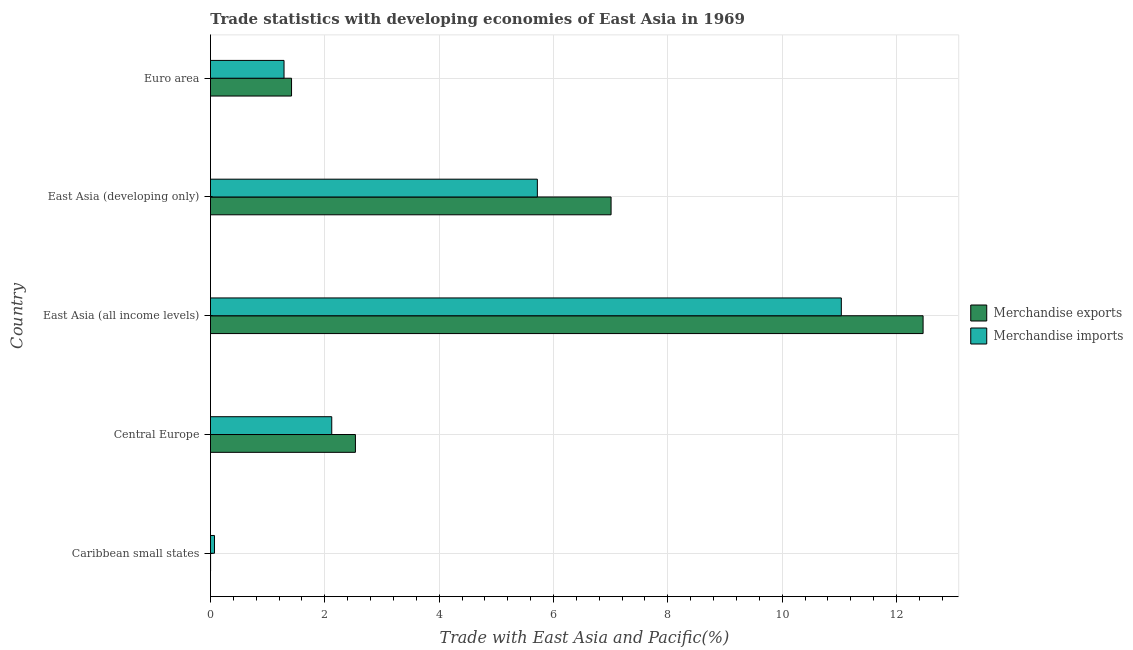How many different coloured bars are there?
Your answer should be very brief. 2. How many bars are there on the 1st tick from the top?
Keep it short and to the point. 2. What is the label of the 5th group of bars from the top?
Your answer should be compact. Caribbean small states. What is the merchandise imports in East Asia (all income levels)?
Your response must be concise. 11.03. Across all countries, what is the maximum merchandise exports?
Offer a very short reply. 12.46. Across all countries, what is the minimum merchandise imports?
Your answer should be compact. 0.07. In which country was the merchandise imports maximum?
Your response must be concise. East Asia (all income levels). In which country was the merchandise exports minimum?
Provide a succinct answer. Caribbean small states. What is the total merchandise imports in the graph?
Offer a terse response. 20.23. What is the difference between the merchandise exports in Caribbean small states and that in Euro area?
Provide a succinct answer. -1.42. What is the difference between the merchandise imports in Central Europe and the merchandise exports in Caribbean small states?
Offer a terse response. 2.12. What is the average merchandise imports per country?
Offer a very short reply. 4.05. What is the difference between the merchandise exports and merchandise imports in Caribbean small states?
Make the answer very short. -0.07. In how many countries, is the merchandise imports greater than 2.4 %?
Your response must be concise. 2. What is the ratio of the merchandise exports in East Asia (all income levels) to that in East Asia (developing only)?
Provide a short and direct response. 1.78. Is the merchandise imports in Caribbean small states less than that in Central Europe?
Provide a short and direct response. Yes. What is the difference between the highest and the second highest merchandise exports?
Provide a short and direct response. 5.46. What is the difference between the highest and the lowest merchandise exports?
Keep it short and to the point. 12.46. What does the 1st bar from the top in Caribbean small states represents?
Provide a short and direct response. Merchandise imports. Are all the bars in the graph horizontal?
Offer a very short reply. Yes. How many countries are there in the graph?
Make the answer very short. 5. What is the difference between two consecutive major ticks on the X-axis?
Your answer should be very brief. 2. Does the graph contain any zero values?
Ensure brevity in your answer.  No. Does the graph contain grids?
Ensure brevity in your answer.  Yes. How many legend labels are there?
Make the answer very short. 2. What is the title of the graph?
Your response must be concise. Trade statistics with developing economies of East Asia in 1969. What is the label or title of the X-axis?
Your response must be concise. Trade with East Asia and Pacific(%). What is the Trade with East Asia and Pacific(%) of Merchandise exports in Caribbean small states?
Offer a very short reply. 0. What is the Trade with East Asia and Pacific(%) of Merchandise imports in Caribbean small states?
Keep it short and to the point. 0.07. What is the Trade with East Asia and Pacific(%) in Merchandise exports in Central Europe?
Make the answer very short. 2.54. What is the Trade with East Asia and Pacific(%) of Merchandise imports in Central Europe?
Provide a short and direct response. 2.12. What is the Trade with East Asia and Pacific(%) of Merchandise exports in East Asia (all income levels)?
Offer a terse response. 12.46. What is the Trade with East Asia and Pacific(%) of Merchandise imports in East Asia (all income levels)?
Your answer should be very brief. 11.03. What is the Trade with East Asia and Pacific(%) in Merchandise exports in East Asia (developing only)?
Make the answer very short. 7.01. What is the Trade with East Asia and Pacific(%) in Merchandise imports in East Asia (developing only)?
Ensure brevity in your answer.  5.72. What is the Trade with East Asia and Pacific(%) in Merchandise exports in Euro area?
Give a very brief answer. 1.42. What is the Trade with East Asia and Pacific(%) of Merchandise imports in Euro area?
Your response must be concise. 1.29. Across all countries, what is the maximum Trade with East Asia and Pacific(%) of Merchandise exports?
Give a very brief answer. 12.46. Across all countries, what is the maximum Trade with East Asia and Pacific(%) in Merchandise imports?
Provide a short and direct response. 11.03. Across all countries, what is the minimum Trade with East Asia and Pacific(%) of Merchandise exports?
Offer a very short reply. 0. Across all countries, what is the minimum Trade with East Asia and Pacific(%) of Merchandise imports?
Your answer should be compact. 0.07. What is the total Trade with East Asia and Pacific(%) in Merchandise exports in the graph?
Offer a very short reply. 23.43. What is the total Trade with East Asia and Pacific(%) in Merchandise imports in the graph?
Keep it short and to the point. 20.23. What is the difference between the Trade with East Asia and Pacific(%) in Merchandise exports in Caribbean small states and that in Central Europe?
Keep it short and to the point. -2.53. What is the difference between the Trade with East Asia and Pacific(%) in Merchandise imports in Caribbean small states and that in Central Europe?
Offer a terse response. -2.05. What is the difference between the Trade with East Asia and Pacific(%) in Merchandise exports in Caribbean small states and that in East Asia (all income levels)?
Provide a short and direct response. -12.46. What is the difference between the Trade with East Asia and Pacific(%) of Merchandise imports in Caribbean small states and that in East Asia (all income levels)?
Make the answer very short. -10.96. What is the difference between the Trade with East Asia and Pacific(%) of Merchandise exports in Caribbean small states and that in East Asia (developing only)?
Provide a short and direct response. -7.01. What is the difference between the Trade with East Asia and Pacific(%) of Merchandise imports in Caribbean small states and that in East Asia (developing only)?
Your answer should be very brief. -5.65. What is the difference between the Trade with East Asia and Pacific(%) in Merchandise exports in Caribbean small states and that in Euro area?
Ensure brevity in your answer.  -1.42. What is the difference between the Trade with East Asia and Pacific(%) of Merchandise imports in Caribbean small states and that in Euro area?
Give a very brief answer. -1.22. What is the difference between the Trade with East Asia and Pacific(%) in Merchandise exports in Central Europe and that in East Asia (all income levels)?
Give a very brief answer. -9.93. What is the difference between the Trade with East Asia and Pacific(%) in Merchandise imports in Central Europe and that in East Asia (all income levels)?
Your response must be concise. -8.91. What is the difference between the Trade with East Asia and Pacific(%) of Merchandise exports in Central Europe and that in East Asia (developing only)?
Provide a succinct answer. -4.47. What is the difference between the Trade with East Asia and Pacific(%) of Merchandise imports in Central Europe and that in East Asia (developing only)?
Keep it short and to the point. -3.6. What is the difference between the Trade with East Asia and Pacific(%) of Merchandise exports in Central Europe and that in Euro area?
Provide a succinct answer. 1.12. What is the difference between the Trade with East Asia and Pacific(%) in Merchandise imports in Central Europe and that in Euro area?
Provide a succinct answer. 0.83. What is the difference between the Trade with East Asia and Pacific(%) in Merchandise exports in East Asia (all income levels) and that in East Asia (developing only)?
Offer a terse response. 5.46. What is the difference between the Trade with East Asia and Pacific(%) in Merchandise imports in East Asia (all income levels) and that in East Asia (developing only)?
Provide a short and direct response. 5.32. What is the difference between the Trade with East Asia and Pacific(%) in Merchandise exports in East Asia (all income levels) and that in Euro area?
Make the answer very short. 11.05. What is the difference between the Trade with East Asia and Pacific(%) of Merchandise imports in East Asia (all income levels) and that in Euro area?
Keep it short and to the point. 9.75. What is the difference between the Trade with East Asia and Pacific(%) of Merchandise exports in East Asia (developing only) and that in Euro area?
Keep it short and to the point. 5.59. What is the difference between the Trade with East Asia and Pacific(%) in Merchandise imports in East Asia (developing only) and that in Euro area?
Keep it short and to the point. 4.43. What is the difference between the Trade with East Asia and Pacific(%) in Merchandise exports in Caribbean small states and the Trade with East Asia and Pacific(%) in Merchandise imports in Central Europe?
Provide a succinct answer. -2.12. What is the difference between the Trade with East Asia and Pacific(%) in Merchandise exports in Caribbean small states and the Trade with East Asia and Pacific(%) in Merchandise imports in East Asia (all income levels)?
Make the answer very short. -11.03. What is the difference between the Trade with East Asia and Pacific(%) in Merchandise exports in Caribbean small states and the Trade with East Asia and Pacific(%) in Merchandise imports in East Asia (developing only)?
Provide a succinct answer. -5.72. What is the difference between the Trade with East Asia and Pacific(%) of Merchandise exports in Caribbean small states and the Trade with East Asia and Pacific(%) of Merchandise imports in Euro area?
Give a very brief answer. -1.28. What is the difference between the Trade with East Asia and Pacific(%) of Merchandise exports in Central Europe and the Trade with East Asia and Pacific(%) of Merchandise imports in East Asia (all income levels)?
Ensure brevity in your answer.  -8.5. What is the difference between the Trade with East Asia and Pacific(%) of Merchandise exports in Central Europe and the Trade with East Asia and Pacific(%) of Merchandise imports in East Asia (developing only)?
Give a very brief answer. -3.18. What is the difference between the Trade with East Asia and Pacific(%) of Merchandise exports in Central Europe and the Trade with East Asia and Pacific(%) of Merchandise imports in Euro area?
Your answer should be very brief. 1.25. What is the difference between the Trade with East Asia and Pacific(%) in Merchandise exports in East Asia (all income levels) and the Trade with East Asia and Pacific(%) in Merchandise imports in East Asia (developing only)?
Offer a very short reply. 6.75. What is the difference between the Trade with East Asia and Pacific(%) in Merchandise exports in East Asia (all income levels) and the Trade with East Asia and Pacific(%) in Merchandise imports in Euro area?
Ensure brevity in your answer.  11.18. What is the difference between the Trade with East Asia and Pacific(%) of Merchandise exports in East Asia (developing only) and the Trade with East Asia and Pacific(%) of Merchandise imports in Euro area?
Provide a short and direct response. 5.72. What is the average Trade with East Asia and Pacific(%) in Merchandise exports per country?
Your answer should be compact. 4.69. What is the average Trade with East Asia and Pacific(%) in Merchandise imports per country?
Your answer should be very brief. 4.05. What is the difference between the Trade with East Asia and Pacific(%) in Merchandise exports and Trade with East Asia and Pacific(%) in Merchandise imports in Caribbean small states?
Provide a short and direct response. -0.07. What is the difference between the Trade with East Asia and Pacific(%) in Merchandise exports and Trade with East Asia and Pacific(%) in Merchandise imports in Central Europe?
Your answer should be compact. 0.41. What is the difference between the Trade with East Asia and Pacific(%) of Merchandise exports and Trade with East Asia and Pacific(%) of Merchandise imports in East Asia (all income levels)?
Offer a terse response. 1.43. What is the difference between the Trade with East Asia and Pacific(%) of Merchandise exports and Trade with East Asia and Pacific(%) of Merchandise imports in East Asia (developing only)?
Provide a succinct answer. 1.29. What is the difference between the Trade with East Asia and Pacific(%) in Merchandise exports and Trade with East Asia and Pacific(%) in Merchandise imports in Euro area?
Keep it short and to the point. 0.13. What is the ratio of the Trade with East Asia and Pacific(%) of Merchandise exports in Caribbean small states to that in Central Europe?
Your answer should be very brief. 0. What is the ratio of the Trade with East Asia and Pacific(%) in Merchandise imports in Caribbean small states to that in Central Europe?
Ensure brevity in your answer.  0.03. What is the ratio of the Trade with East Asia and Pacific(%) in Merchandise imports in Caribbean small states to that in East Asia (all income levels)?
Provide a short and direct response. 0.01. What is the ratio of the Trade with East Asia and Pacific(%) in Merchandise imports in Caribbean small states to that in East Asia (developing only)?
Your answer should be compact. 0.01. What is the ratio of the Trade with East Asia and Pacific(%) of Merchandise exports in Caribbean small states to that in Euro area?
Ensure brevity in your answer.  0. What is the ratio of the Trade with East Asia and Pacific(%) in Merchandise imports in Caribbean small states to that in Euro area?
Keep it short and to the point. 0.05. What is the ratio of the Trade with East Asia and Pacific(%) in Merchandise exports in Central Europe to that in East Asia (all income levels)?
Your response must be concise. 0.2. What is the ratio of the Trade with East Asia and Pacific(%) of Merchandise imports in Central Europe to that in East Asia (all income levels)?
Offer a very short reply. 0.19. What is the ratio of the Trade with East Asia and Pacific(%) of Merchandise exports in Central Europe to that in East Asia (developing only)?
Your response must be concise. 0.36. What is the ratio of the Trade with East Asia and Pacific(%) in Merchandise imports in Central Europe to that in East Asia (developing only)?
Make the answer very short. 0.37. What is the ratio of the Trade with East Asia and Pacific(%) of Merchandise exports in Central Europe to that in Euro area?
Offer a terse response. 1.79. What is the ratio of the Trade with East Asia and Pacific(%) of Merchandise imports in Central Europe to that in Euro area?
Offer a terse response. 1.65. What is the ratio of the Trade with East Asia and Pacific(%) in Merchandise exports in East Asia (all income levels) to that in East Asia (developing only)?
Ensure brevity in your answer.  1.78. What is the ratio of the Trade with East Asia and Pacific(%) of Merchandise imports in East Asia (all income levels) to that in East Asia (developing only)?
Offer a terse response. 1.93. What is the ratio of the Trade with East Asia and Pacific(%) in Merchandise exports in East Asia (all income levels) to that in Euro area?
Give a very brief answer. 8.79. What is the ratio of the Trade with East Asia and Pacific(%) of Merchandise imports in East Asia (all income levels) to that in Euro area?
Offer a terse response. 8.58. What is the ratio of the Trade with East Asia and Pacific(%) in Merchandise exports in East Asia (developing only) to that in Euro area?
Your response must be concise. 4.94. What is the ratio of the Trade with East Asia and Pacific(%) of Merchandise imports in East Asia (developing only) to that in Euro area?
Your answer should be very brief. 4.44. What is the difference between the highest and the second highest Trade with East Asia and Pacific(%) in Merchandise exports?
Provide a succinct answer. 5.46. What is the difference between the highest and the second highest Trade with East Asia and Pacific(%) of Merchandise imports?
Ensure brevity in your answer.  5.32. What is the difference between the highest and the lowest Trade with East Asia and Pacific(%) of Merchandise exports?
Make the answer very short. 12.46. What is the difference between the highest and the lowest Trade with East Asia and Pacific(%) of Merchandise imports?
Give a very brief answer. 10.96. 